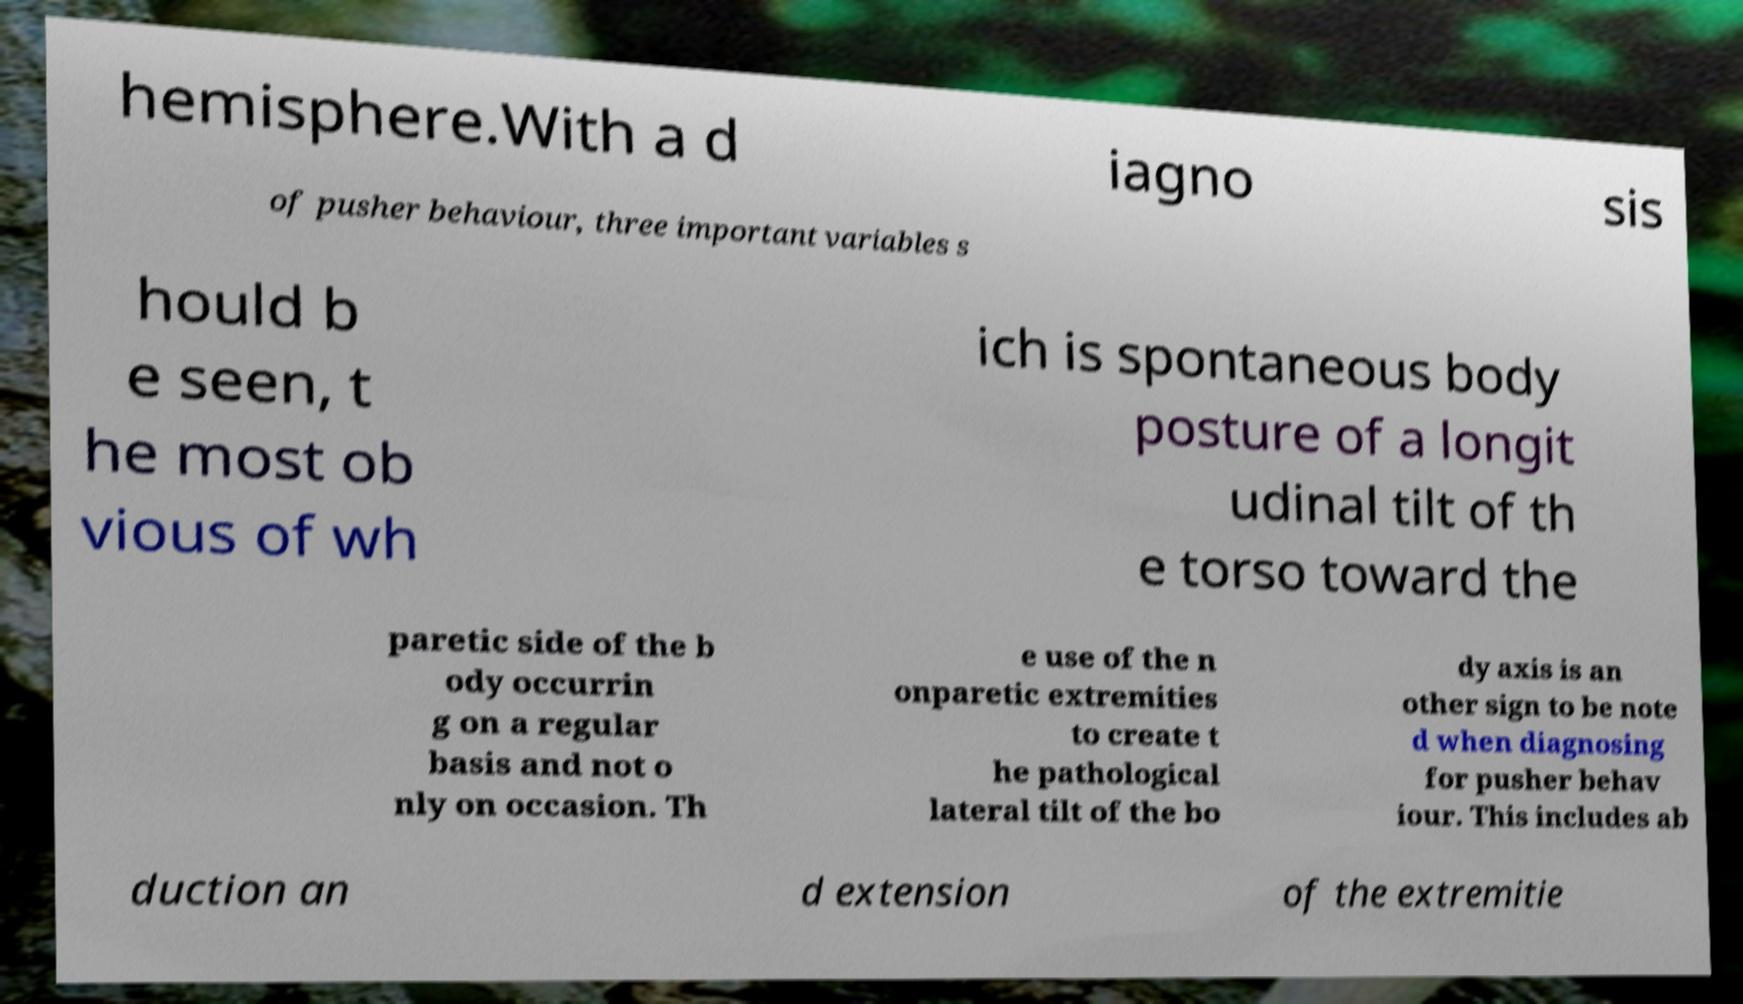For documentation purposes, I need the text within this image transcribed. Could you provide that? hemisphere.With a d iagno sis of pusher behaviour, three important variables s hould b e seen, t he most ob vious of wh ich is spontaneous body posture of a longit udinal tilt of th e torso toward the paretic side of the b ody occurrin g on a regular basis and not o nly on occasion. Th e use of the n onparetic extremities to create t he pathological lateral tilt of the bo dy axis is an other sign to be note d when diagnosing for pusher behav iour. This includes ab duction an d extension of the extremitie 